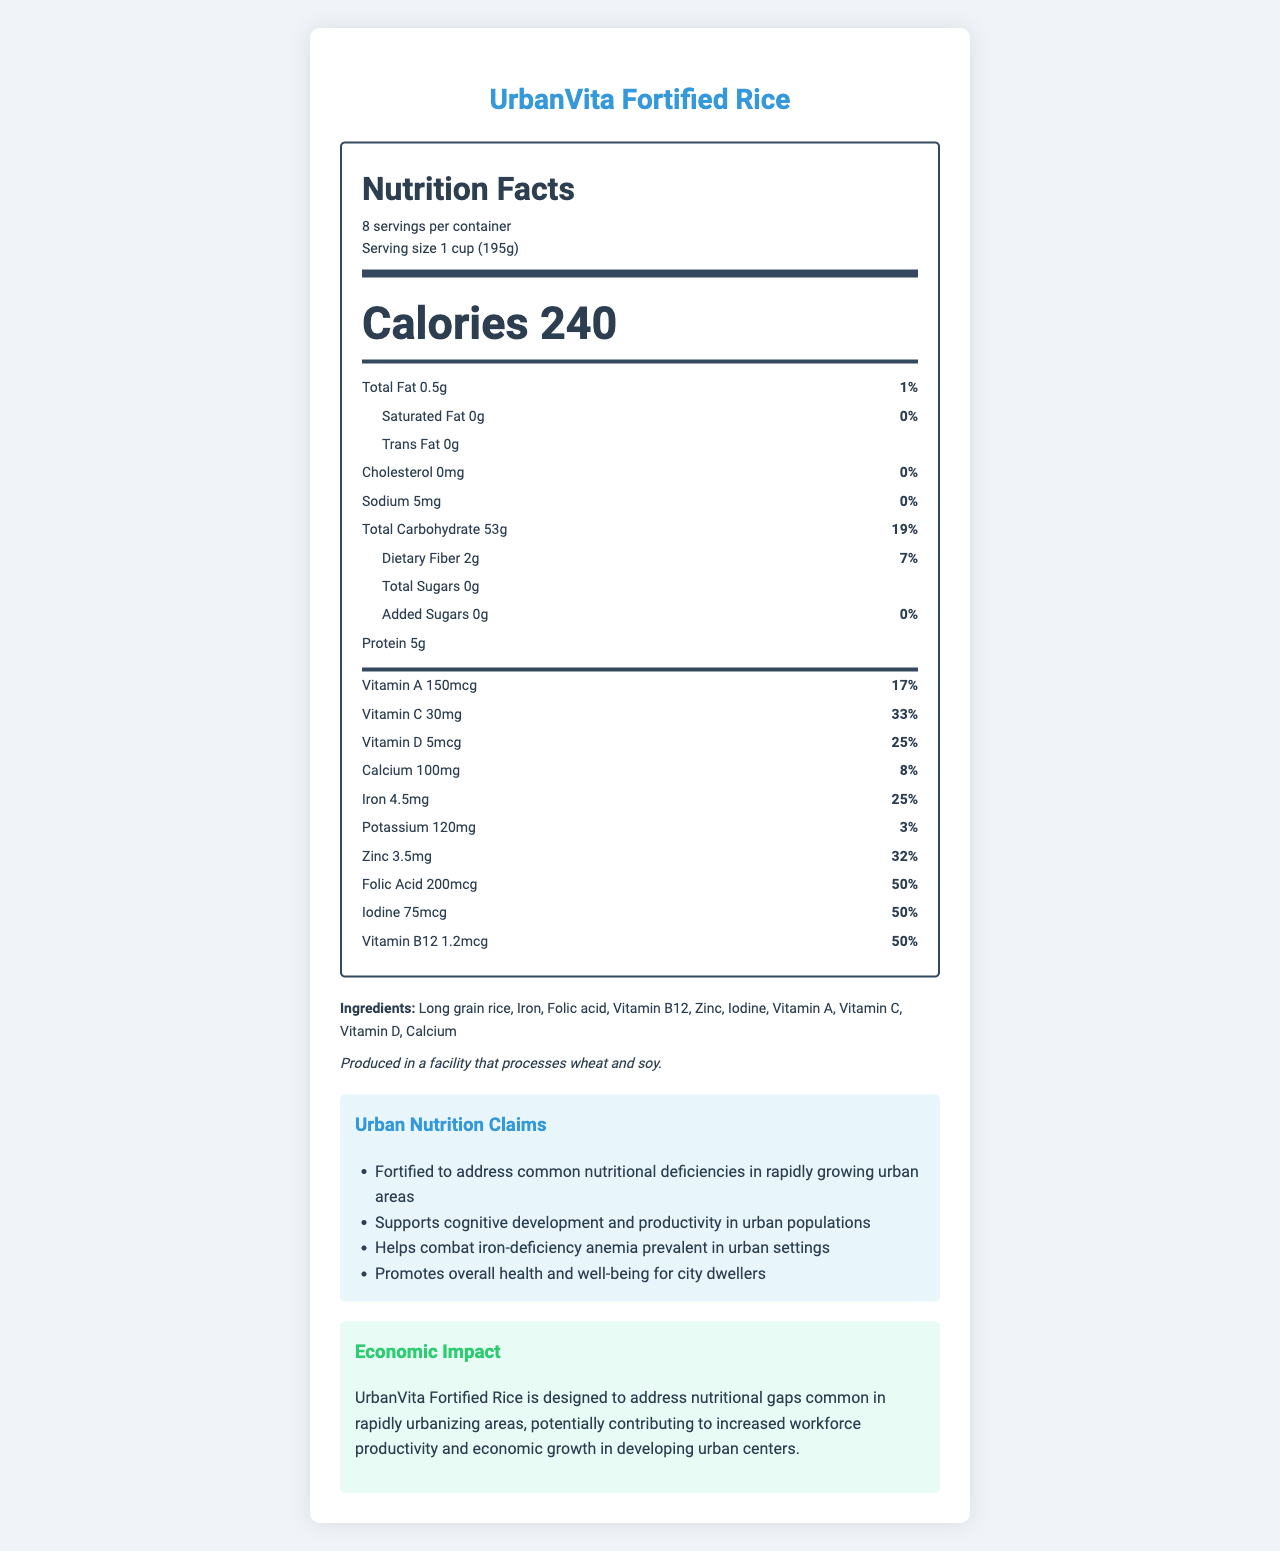what is the serving size? The serving size is listed as "1 cup (195g)" in the document.
Answer: 1 cup (195g) how many servings are there per container? The document states that there are 8 servings per container.
Answer: 8 how many calories are there per serving? The document lists the calories per serving as 240.
Answer: 240 what is the total fat content per serving? The document mentions that the total fat content per serving is 0.5g.
Answer: 0.5g which nutrient has the highest percent daily value? Both Folic Acid and Iodine have the highest percent daily value at 50%, as indicated in the document.
Answer: Folic Acid and Iodine, both at 50% where is this product produced with respect to allergens? The allergen statement in the document explains that the product is produced in a facility that processes wheat and soy.
Answer: Produced in a facility that processes wheat and soy. which vitamin has a 25% daily value per serving? A. Vitamin A B. Vitamin C C. Vitamin D D. Vitamin B12 The document states that Vitamin D has a daily value of 25%.
Answer: C. Vitamin D how much iron is there per serving? A. 2mg B. 4.5mg C. 6mg D. 8mg The document specifies that each serving contains 4.5mg of iron.
Answer: B. 4.5mg is the product suitable for someone avoiding cholesterol? The document lists the cholesterol content as 0mg, making it suitable for someone avoiding cholesterol.
Answer: Yes summarize the main idea of the document. The document provides comprehensive nutritional information, including vitamins, minerals, and calories, as well as the intended benefits and economic impact of the product on urban populations.
Answer: UrbanVita Fortified Rice is a food product designed to address nutritional deficiencies common in urban areas, providing various essential nutrients such as vitamins and minerals. It has a detailed nutrition facts label, an allergen statement, and claims geared toward supporting urban nutrition and economic productivity. what are the potential economic benefits mentioned in the document? The economic impact statement suggests that UrbanVita Fortified Rice could contribute to increased workforce productivity and economic growth in rapidly urbanizing areas.
Answer: Increased workforce productivity and economic growth in developing urban centers what is the sodium content per serving? The document lists the sodium content per serving as 5mg.
Answer: 5mg how much zinc is there per serving? According to the document, there is 3.5mg of zinc per serving.
Answer: 3.5mg how much vitamin C is there per serving in terms of percent daily value? The document states that each serving contains 30mg of vitamin C, which is 33% of the daily value.
Answer: 33% what ingredient is used to address iron-deficiency anemia? The document explicitly mentions that one of the claims of UrbanVita Fortified Rice is to help combat iron-deficiency anemia, and iron is listed as one of the main ingredients.
Answer: Iron can you find the production cost of UrbanVita Fortified Rice? The document does not provide any information about the production cost of UrbanVita Fortified Rice.
Answer: Cannot be determined 